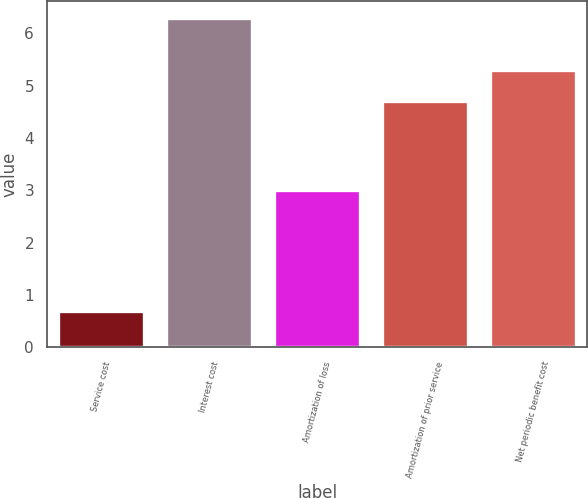Convert chart to OTSL. <chart><loc_0><loc_0><loc_500><loc_500><bar_chart><fcel>Service cost<fcel>Interest cost<fcel>Amortization of loss<fcel>Amortization of prior service<fcel>Net periodic benefit cost<nl><fcel>0.7<fcel>6.3<fcel>3<fcel>4.7<fcel>5.3<nl></chart> 